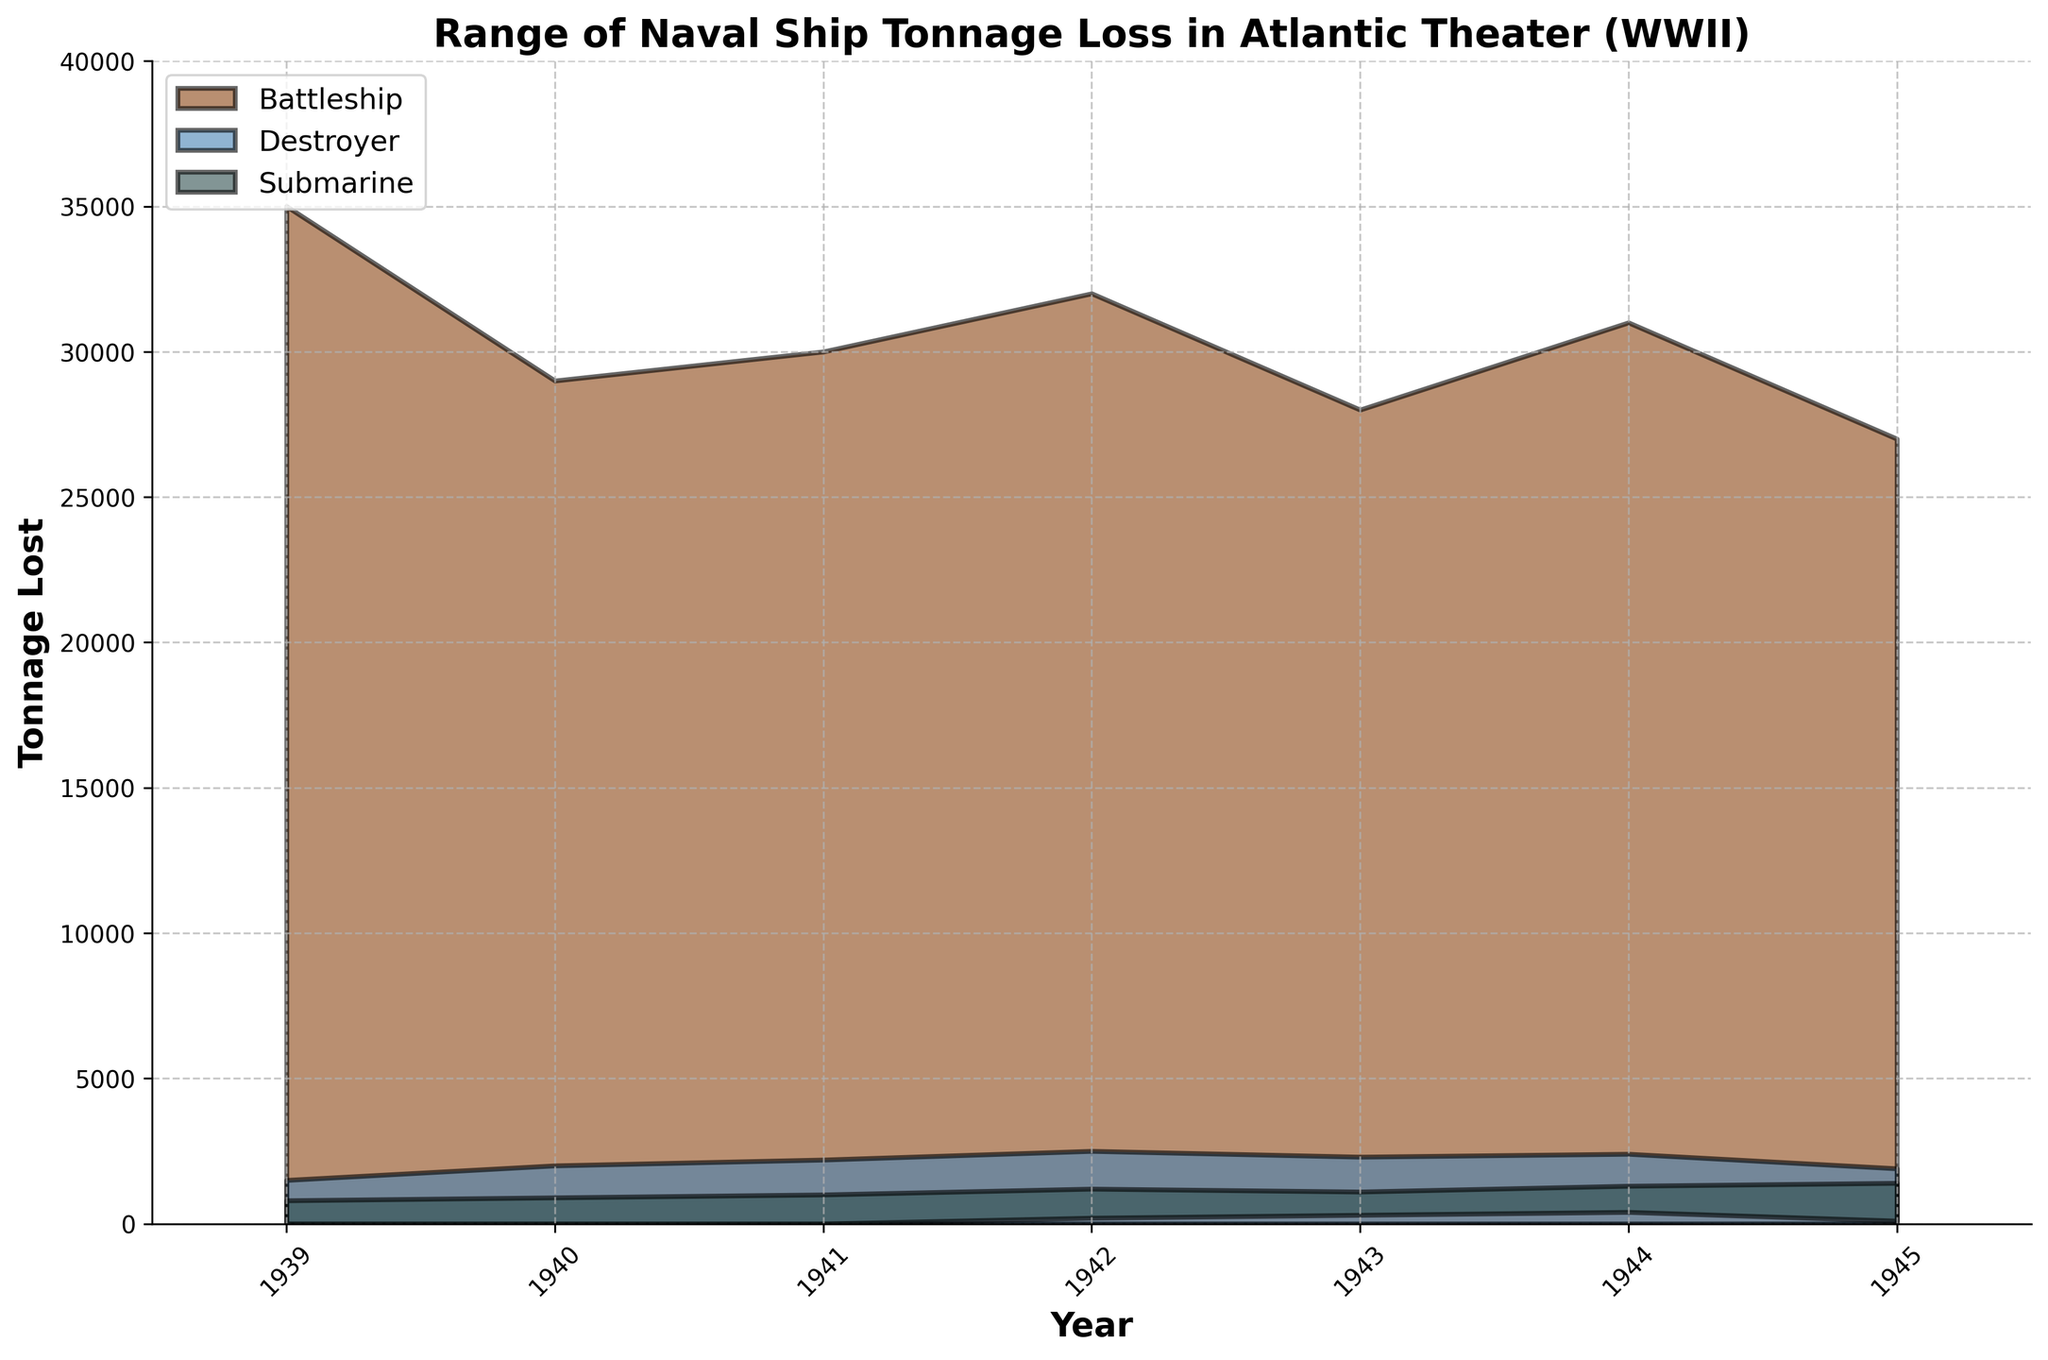What is the title of the chart? The title of the chart is displayed at the top of the figure and is intended to provide a succinct description of what the chart represents.
Answer: Range of Naval Ship Tonnage Loss in Atlantic Theater (WWII) What years are included in the chart? The years included in the chart are indicated along the x-axis through the ticks and labels.
Answer: 1939 to 1945 Which type of vessel experienced the highest maximum tonnage loss in 1943? To determine this, look at the highest point on the chart for each vessel type in 1943 and identify the one with the highest value.
Answer: Battleship How did the range of tonnage loss for submarines change from 1942 to 1943? Observe the min and max tonnage loss for submarines in 1942 and compare them to those in 1943. The min tonnage increased from 200 to 300, and the max tonnage decreased from 1200 to 1100.
Answer: The range shifted upwards slightly for the minimum and reduced for the maximum Which type of vessel shows a continuous increase in the minimum tonnage lost from 1941 to 1944? Examine the minimum tonnage lost for each vessel type over the years 1941 to 1944 and identify the one that increases every year.
Answer: Submarine Calculate the average maximum tonnage lost for battleships between 1939 and 1945. Sum the maximum tonnage lost for battleships over these years (35000 + 29000 + 30000 + 32000 + 28000 + 31000 + 27000) and divide by the number of years. This gives (35000 + 29000 + 30000 + 32000 + 28000 + 31000 + 27000) / 7 = 30,285.7.
Answer: 30,285.7 Compare the minimum tonnage loss for destroyers in 1940 and 1945. Which is higher? Identify the minimum tonnage loss for destroyers in 1940 and 1945 and compare them, both are zero.
Answer: They are the same Which year had the highest maximum tonnage loss for submarines? Look at the maximum values for submarines across all years and identify the highest point.
Answer: 1945 What colors are used to represent different types of vessels in the chart? Notice the color coding for each vessel type in the legend.
Answer: Battleship is brown, Destroyer is blue, Submarine is dark gray What was the range of tonnage loss for destroyers in 1942? Identify the minimum and maximum tonnage loss for destroyers in 1942 directly from the chart. The range is from 0 to 2500.
Answer: 0 - 2500 